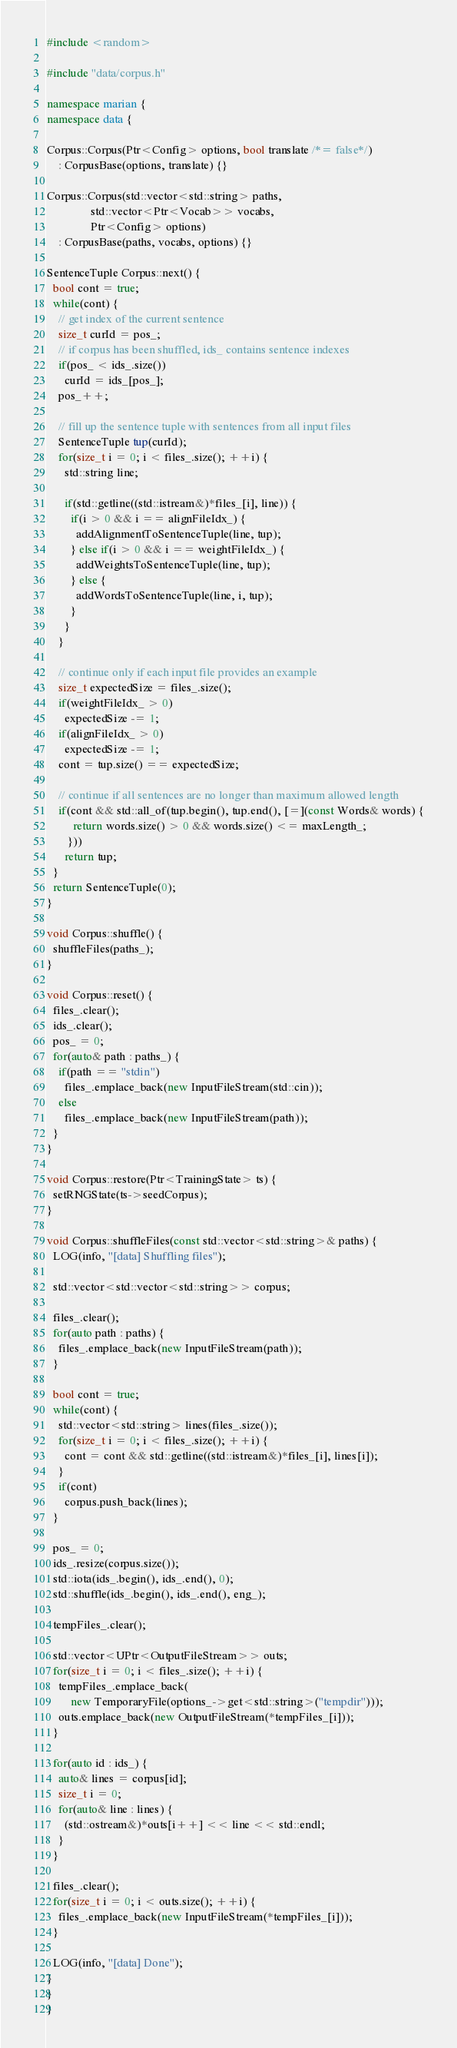Convert code to text. <code><loc_0><loc_0><loc_500><loc_500><_C++_>#include <random>

#include "data/corpus.h"

namespace marian {
namespace data {

Corpus::Corpus(Ptr<Config> options, bool translate /*= false*/)
    : CorpusBase(options, translate) {}

Corpus::Corpus(std::vector<std::string> paths,
               std::vector<Ptr<Vocab>> vocabs,
               Ptr<Config> options)
    : CorpusBase(paths, vocabs, options) {}

SentenceTuple Corpus::next() {
  bool cont = true;
  while(cont) {
    // get index of the current sentence
    size_t curId = pos_;
    // if corpus has been shuffled, ids_ contains sentence indexes
    if(pos_ < ids_.size())
      curId = ids_[pos_];
    pos_++;

    // fill up the sentence tuple with sentences from all input files
    SentenceTuple tup(curId);
    for(size_t i = 0; i < files_.size(); ++i) {
      std::string line;

      if(std::getline((std::istream&)*files_[i], line)) {
        if(i > 0 && i == alignFileIdx_) {
          addAlignmentToSentenceTuple(line, tup);
        } else if(i > 0 && i == weightFileIdx_) {
          addWeightsToSentenceTuple(line, tup);
        } else {
          addWordsToSentenceTuple(line, i, tup);
        }
      }
    }

    // continue only if each input file provides an example
    size_t expectedSize = files_.size();
    if(weightFileIdx_ > 0)
      expectedSize -= 1;
    if(alignFileIdx_ > 0)
      expectedSize -= 1;
    cont = tup.size() == expectedSize;

    // continue if all sentences are no longer than maximum allowed length
    if(cont && std::all_of(tup.begin(), tup.end(), [=](const Words& words) {
         return words.size() > 0 && words.size() <= maxLength_;
       }))
      return tup;
  }
  return SentenceTuple(0);
}

void Corpus::shuffle() {
  shuffleFiles(paths_);
}

void Corpus::reset() {
  files_.clear();
  ids_.clear();
  pos_ = 0;
  for(auto& path : paths_) {
    if(path == "stdin")
      files_.emplace_back(new InputFileStream(std::cin));
    else
      files_.emplace_back(new InputFileStream(path));
  }
}

void Corpus::restore(Ptr<TrainingState> ts) {
  setRNGState(ts->seedCorpus);
}

void Corpus::shuffleFiles(const std::vector<std::string>& paths) {
  LOG(info, "[data] Shuffling files");

  std::vector<std::vector<std::string>> corpus;

  files_.clear();
  for(auto path : paths) {
    files_.emplace_back(new InputFileStream(path));
  }

  bool cont = true;
  while(cont) {
    std::vector<std::string> lines(files_.size());
    for(size_t i = 0; i < files_.size(); ++i) {
      cont = cont && std::getline((std::istream&)*files_[i], lines[i]);
    }
    if(cont)
      corpus.push_back(lines);
  }

  pos_ = 0;
  ids_.resize(corpus.size());
  std::iota(ids_.begin(), ids_.end(), 0);
  std::shuffle(ids_.begin(), ids_.end(), eng_);

  tempFiles_.clear();

  std::vector<UPtr<OutputFileStream>> outs;
  for(size_t i = 0; i < files_.size(); ++i) {
    tempFiles_.emplace_back(
        new TemporaryFile(options_->get<std::string>("tempdir")));
    outs.emplace_back(new OutputFileStream(*tempFiles_[i]));
  }

  for(auto id : ids_) {
    auto& lines = corpus[id];
    size_t i = 0;
    for(auto& line : lines) {
      (std::ostream&)*outs[i++] << line << std::endl;
    }
  }

  files_.clear();
  for(size_t i = 0; i < outs.size(); ++i) {
    files_.emplace_back(new InputFileStream(*tempFiles_[i]));
  }

  LOG(info, "[data] Done");
}
}
}
</code> 